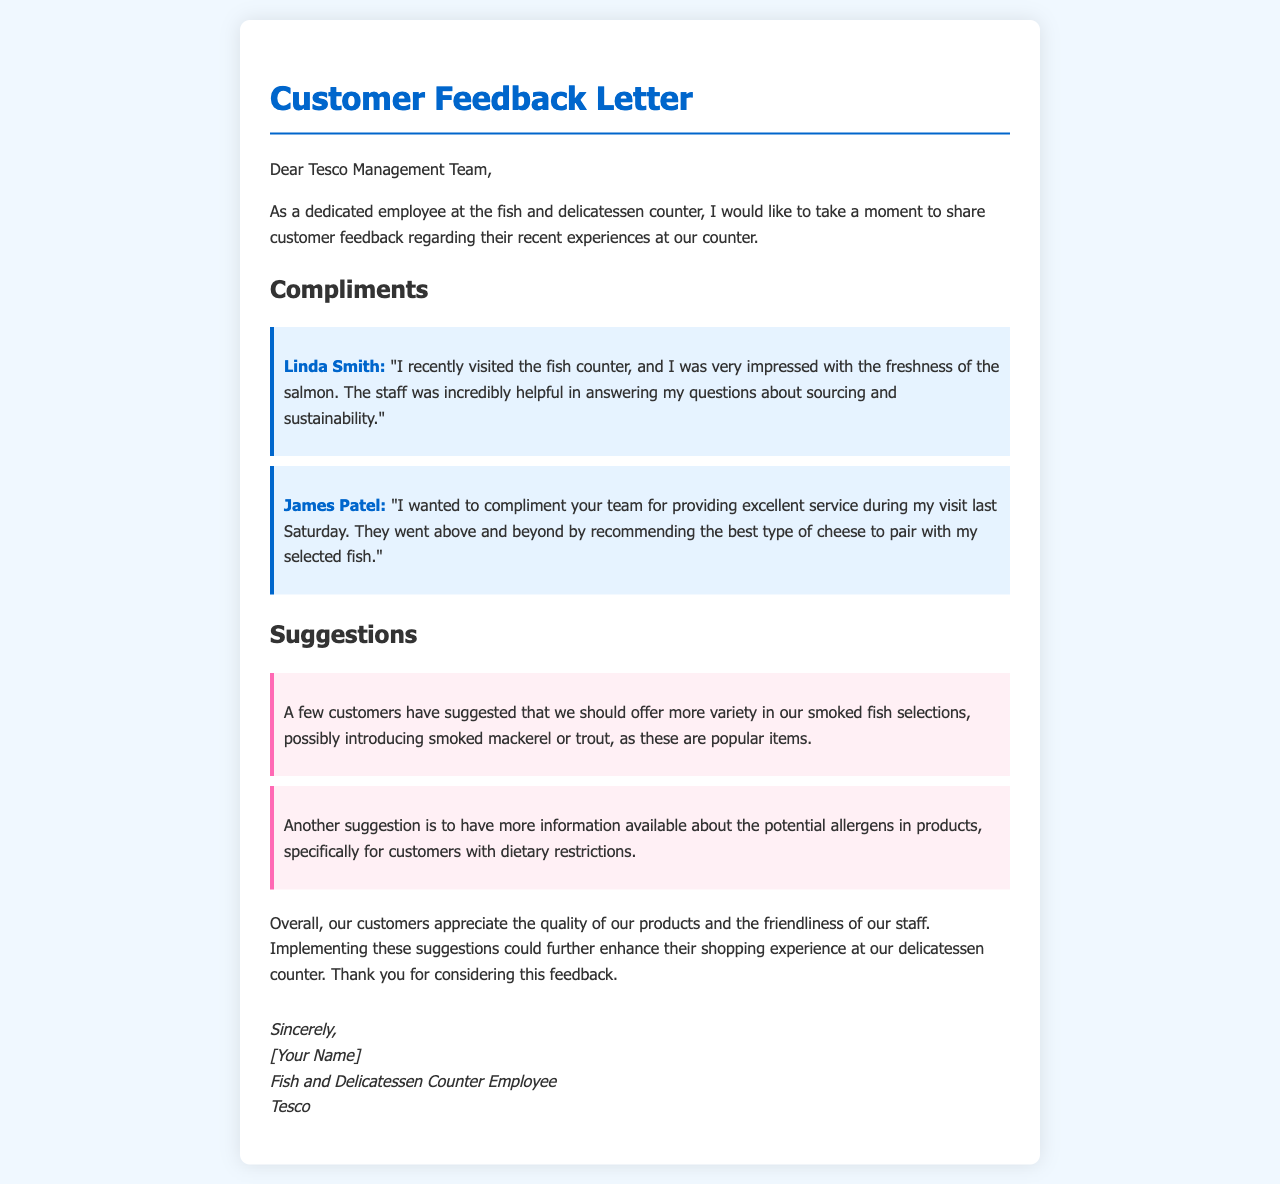What is the name of the first customer mentioned in the compliments? The first customer's name is found within the compliments section of the document.
Answer: Linda Smith What is suggested for the smoked fish selection? The suggestions made by customers regarding smoked fish can be found in the suggestions section.
Answer: Smoked mackerel or trout What was the date of the customer's visit mentioned by James Patel? The specific date of James Patel's visit is mentioned within the context of his compliment.
Answer: Last Saturday What type of information is suggested to improve regarding allergens? The suggestion pertains to providing additional information about a specific concern represented in the document.
Answer: Information about allergens How does the letter conclude regarding customer satisfaction? The conclusion about customer satisfaction can be found in the final paragraph of the letter.
Answer: Appreciate the quality of our products and the friendliness of our staff 